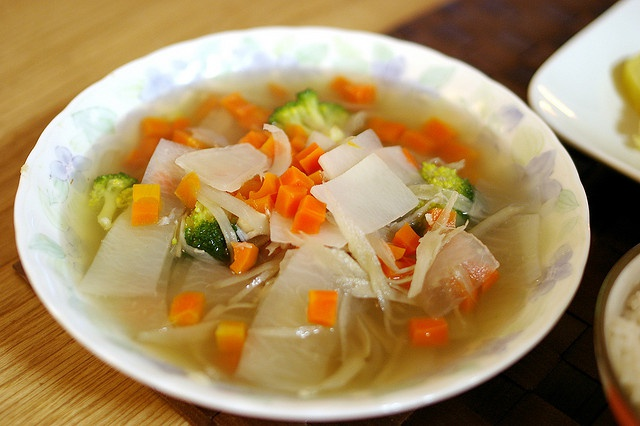Describe the objects in this image and their specific colors. I can see bowl in olive, white, and tan tones, carrot in olive, red, and orange tones, carrot in olive, red, brown, and tan tones, broccoli in olive, black, and tan tones, and broccoli in tan, olive, and khaki tones in this image. 